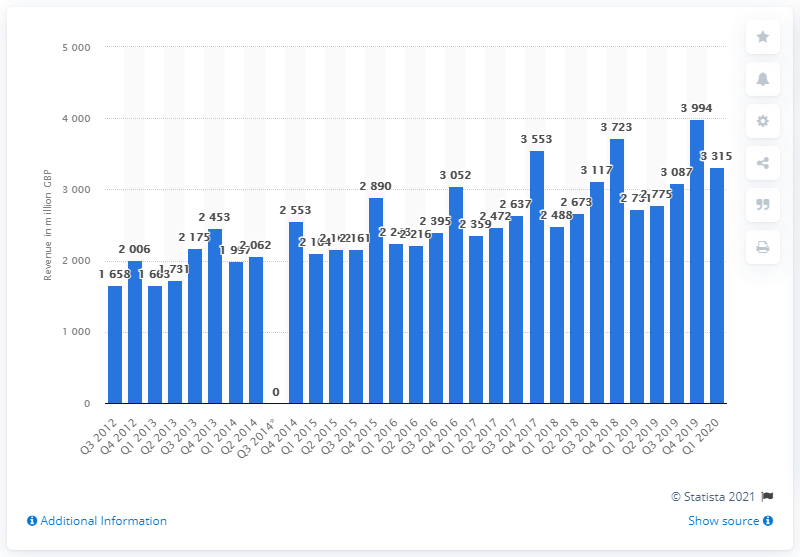Draw attention to some important aspects in this diagram. In the first quarter of 2020, the telecommunications industry generated approximately 3315 million dollars in revenue. 